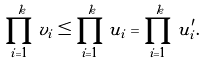<formula> <loc_0><loc_0><loc_500><loc_500>\prod _ { i = 1 } ^ { k } v _ { i } \leq \prod _ { i = 1 } ^ { k } u _ { i } = \prod _ { i = 1 } ^ { k } u ^ { \prime } _ { i } .</formula> 